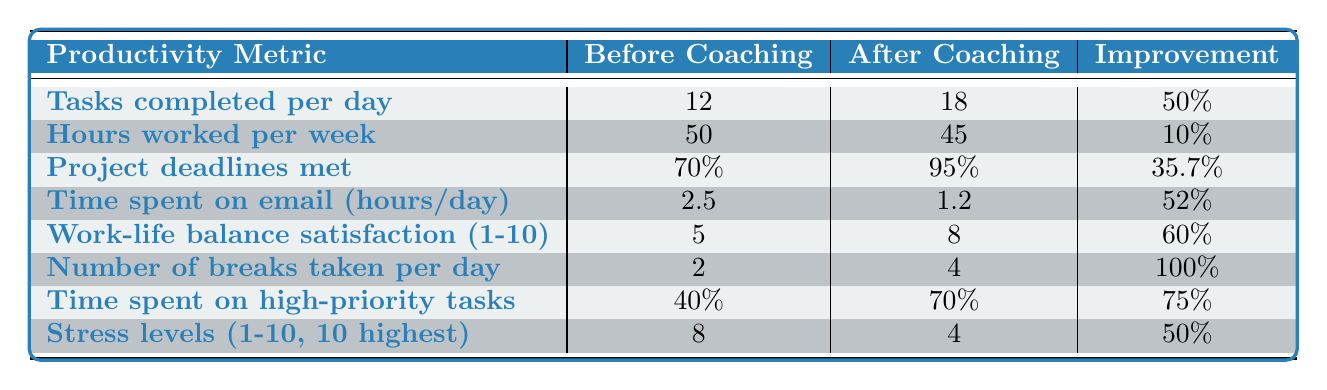What was the improvement percentage for tasks completed per day? According to the table, the metric for tasks completed per day improved from 12 to 18, which is an improvement percentage of 50%.
Answer: 50% How many project deadlines were met after coaching? The table shows that the percentage of project deadlines met after coaching improved to 95%.
Answer: 95% What is the average improvement percentage across all productivity metrics? To calculate the average improvement percentage, we add all the improvement percentages: 50% + 10% + 35.7% + 52% + 60% + 100% + 75% + 50% = 432.7%. Then divide by 8 (the number of metrics), which gives 432.7% / 8 = 54.0875%.
Answer: Approximately 54.09% Did the hours worked per week increase after coaching? The data shows that hours worked per week decreased from 50 to 45, indicating that there was no increase in hours worked after coaching.
Answer: No Which productivity metric showed the greatest improvement percentage? The metric for the number of breaks taken per day improved by 100%, which is the greatest improvement percentage among all metrics listed.
Answer: Number of breaks taken per day Was there a reduction in stress levels after coaching? The data indicates that stress levels decreased from 8 to 4, which confirms a reduction in stress levels after coaching.
Answer: Yes What is the difference in time spent on email per day before and after coaching? The time spent on email decreased from 2.5 hours to 1.2 hours. To find the difference, subtract: 2.5 - 1.2 = 1.3 hours.
Answer: 1.3 hours How did the satisfaction with work-life balance change after coaching? Work-life balance satisfaction improved from a score of 5 to a score of 8, showing a positive change.
Answer: It increased by 3 points What percentage of time was spent on high-priority tasks after coaching? After coaching, it was reported that 70% of time was spent on high-priority tasks.
Answer: 70% Which metric had the lowest improvement percentage? The hours worked per week showed the lowest improvement percentage at 10%.
Answer: Hours worked per week 